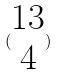<formula> <loc_0><loc_0><loc_500><loc_500>( \begin{matrix} 1 3 \\ 4 \end{matrix} )</formula> 